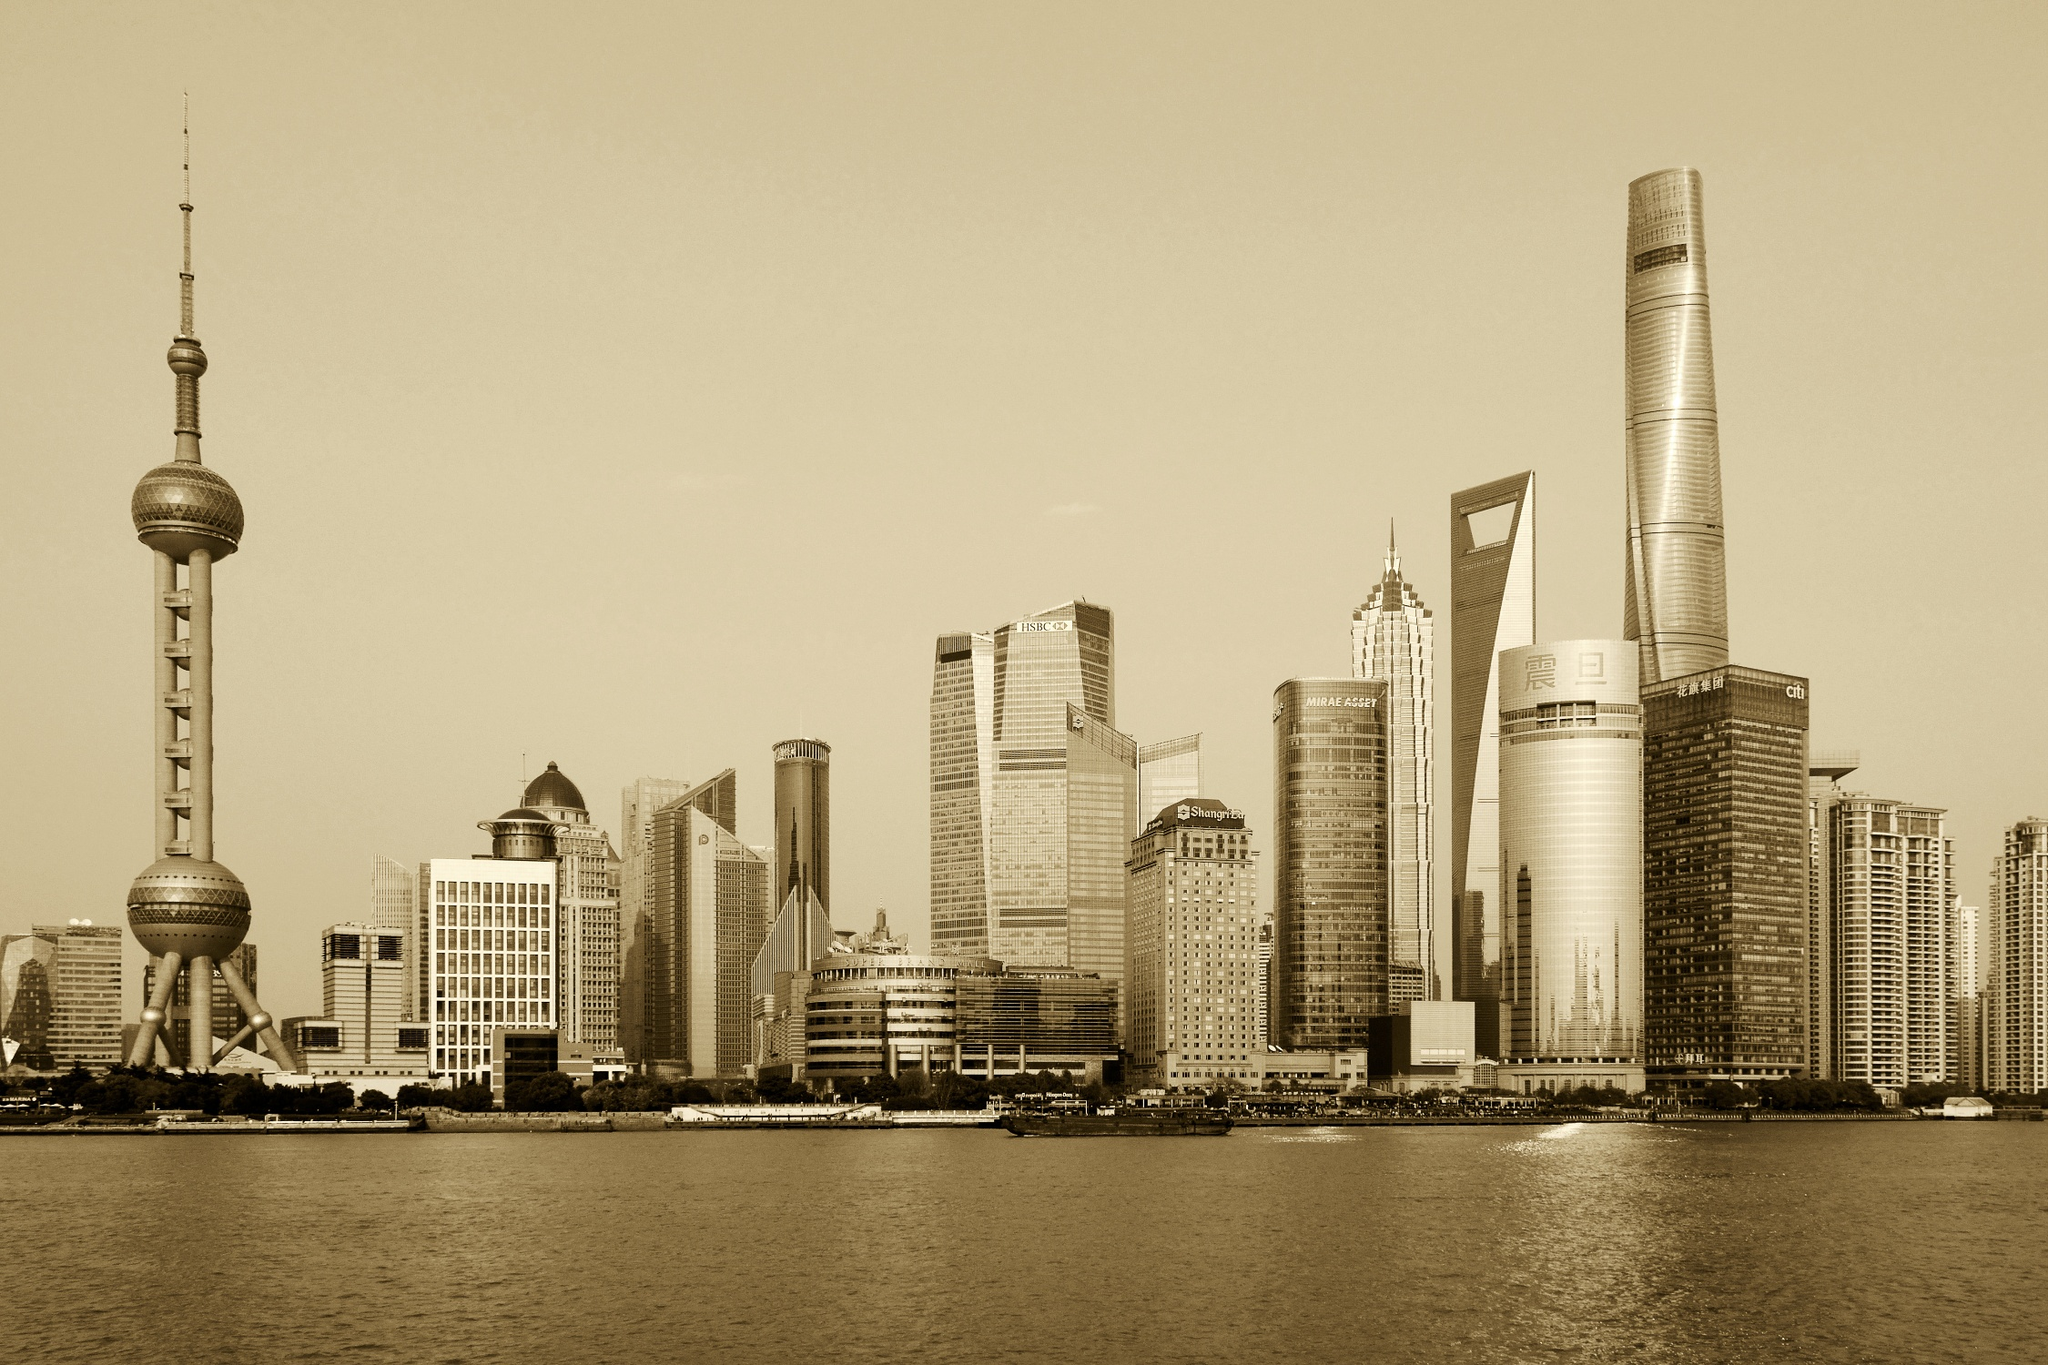Does this skyline reflect Shanghai's economic powerhouse status? Absolutely, this skyline is a testament to Shanghai's status as an economic powerhouse. The prominent skyscrapers, such as the Shanghai Tower, the Shanghai World Financial Center, and the Jin Mao Tower, are home to major financial institutions and multinational corporations. These buildings are symbols of Shanghai’s rapid economic growth and the city’s pivotal role in global commerce. The blend of modern architecture with traditional elements also highlights the city's cultural dynamism and historical significance. 